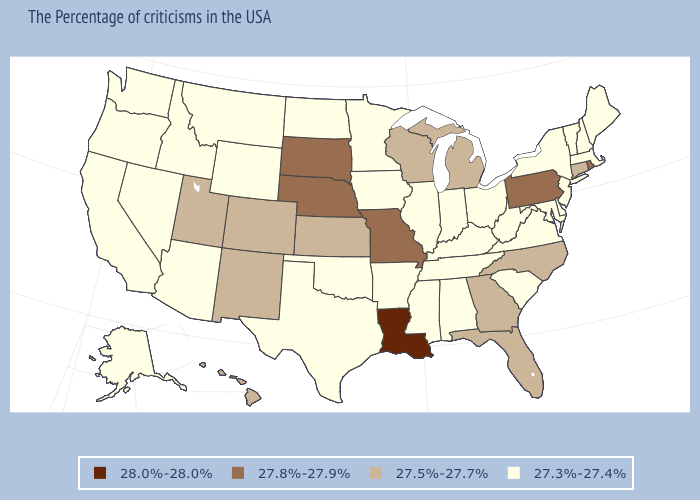Does Connecticut have the highest value in the USA?
Quick response, please. No. Does Pennsylvania have a lower value than Louisiana?
Quick response, please. Yes. What is the lowest value in the USA?
Concise answer only. 27.3%-27.4%. Among the states that border Idaho , which have the lowest value?
Concise answer only. Wyoming, Montana, Nevada, Washington, Oregon. Name the states that have a value in the range 27.3%-27.4%?
Quick response, please. Maine, Massachusetts, New Hampshire, Vermont, New York, New Jersey, Delaware, Maryland, Virginia, South Carolina, West Virginia, Ohio, Kentucky, Indiana, Alabama, Tennessee, Illinois, Mississippi, Arkansas, Minnesota, Iowa, Oklahoma, Texas, North Dakota, Wyoming, Montana, Arizona, Idaho, Nevada, California, Washington, Oregon, Alaska. Which states have the highest value in the USA?
Concise answer only. Louisiana. Name the states that have a value in the range 28.0%-28.0%?
Answer briefly. Louisiana. What is the lowest value in the MidWest?
Give a very brief answer. 27.3%-27.4%. What is the lowest value in states that border Maryland?
Be succinct. 27.3%-27.4%. Name the states that have a value in the range 27.3%-27.4%?
Short answer required. Maine, Massachusetts, New Hampshire, Vermont, New York, New Jersey, Delaware, Maryland, Virginia, South Carolina, West Virginia, Ohio, Kentucky, Indiana, Alabama, Tennessee, Illinois, Mississippi, Arkansas, Minnesota, Iowa, Oklahoma, Texas, North Dakota, Wyoming, Montana, Arizona, Idaho, Nevada, California, Washington, Oregon, Alaska. What is the value of North Carolina?
Give a very brief answer. 27.5%-27.7%. What is the highest value in the USA?
Concise answer only. 28.0%-28.0%. Does the first symbol in the legend represent the smallest category?
Quick response, please. No. Among the states that border Illinois , does Iowa have the lowest value?
Give a very brief answer. Yes. Does Wyoming have the highest value in the USA?
Give a very brief answer. No. 